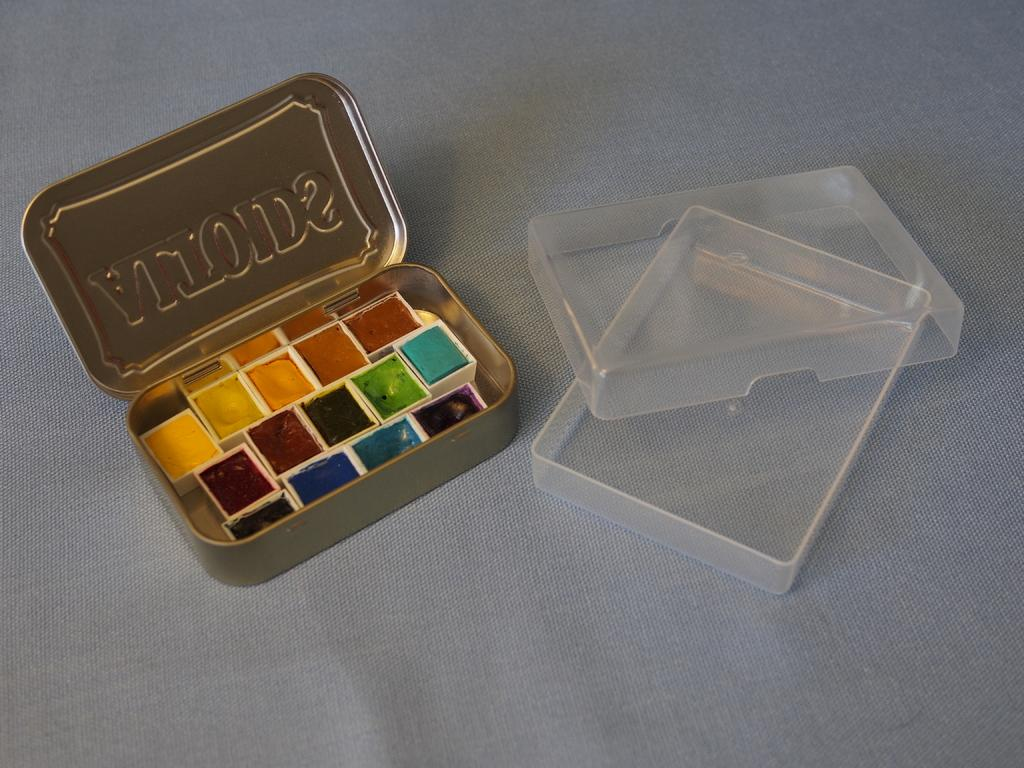<image>
Create a compact narrative representing the image presented. A tin full of small paint samples has the word Altoids stamped in reverse on the lid. 